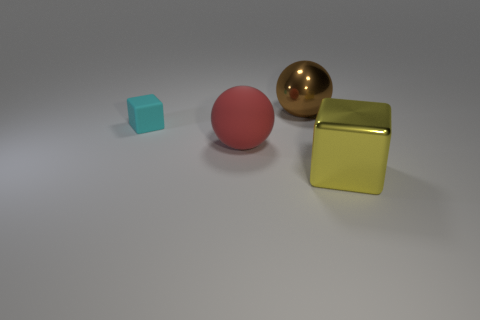How many other things are the same size as the cyan object?
Ensure brevity in your answer.  0. There is a metallic object that is on the right side of the big brown thing; is it the same shape as the tiny cyan matte thing?
Keep it short and to the point. Yes. How many other things are the same shape as the big red rubber thing?
Provide a short and direct response. 1. There is a shiny object that is left of the shiny block; what shape is it?
Ensure brevity in your answer.  Sphere. Is there a large sphere that has the same material as the yellow thing?
Make the answer very short. Yes. The cyan rubber thing is what size?
Your response must be concise. Small. Are there any big brown metallic objects that are in front of the block to the left of the red ball to the right of the small cube?
Your response must be concise. No. How many things are behind the brown metal ball?
Offer a very short reply. 0. How many objects are big shiny things that are in front of the large rubber object or large things in front of the large red matte sphere?
Make the answer very short. 1. Are there more big gray balls than large red matte balls?
Offer a very short reply. No. 